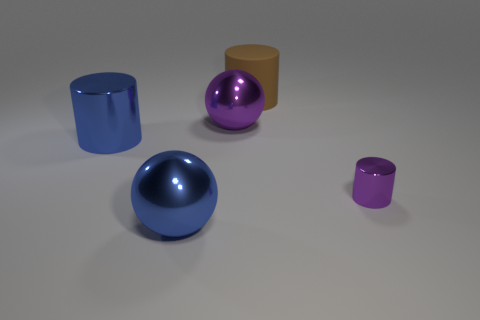Is the number of matte cylinders greater than the number of small yellow metal objects?
Your answer should be very brief. Yes. Are there any other things that have the same color as the tiny metal thing?
Make the answer very short. Yes. How many other things are there of the same size as the brown rubber thing?
Offer a very short reply. 3. What is the material of the big cylinder behind the big cylinder that is on the left side of the big metallic thing that is behind the large shiny cylinder?
Keep it short and to the point. Rubber. Do the tiny purple cylinder and the blue ball that is left of the brown cylinder have the same material?
Keep it short and to the point. Yes. Is the number of large spheres on the right side of the tiny cylinder less than the number of large blue shiny spheres that are in front of the blue metal cylinder?
Your answer should be very brief. Yes. What number of small purple things are the same material as the big blue sphere?
Ensure brevity in your answer.  1. Is there a cylinder that is right of the large cylinder that is on the right side of the big metal ball that is behind the large blue ball?
Give a very brief answer. Yes. How many cylinders are either blue things or rubber objects?
Your response must be concise. 2. There is a large purple metallic object; does it have the same shape as the metallic object that is to the right of the big purple ball?
Keep it short and to the point. No. 